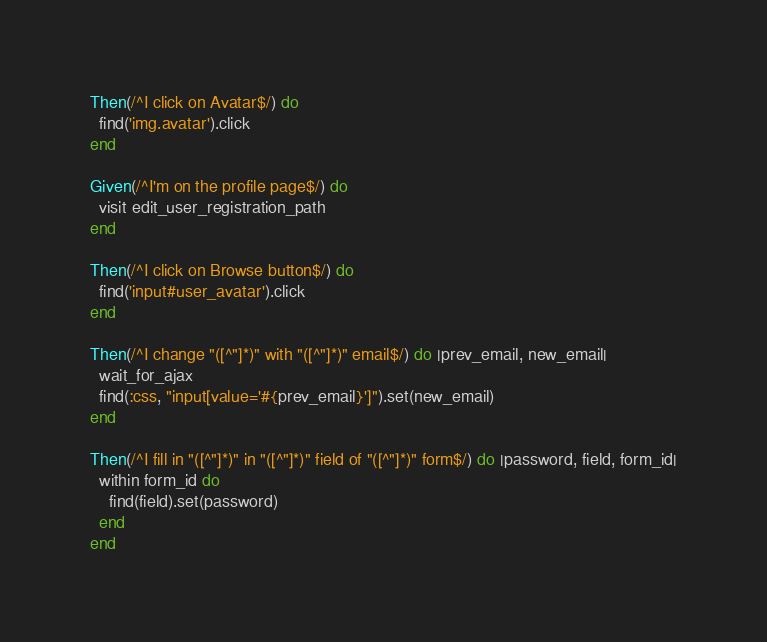<code> <loc_0><loc_0><loc_500><loc_500><_Ruby_>Then(/^I click on Avatar$/) do
  find('img.avatar').click
end

Given(/^I'm on the profile page$/) do
  visit edit_user_registration_path
end

Then(/^I click on Browse button$/) do
  find('input#user_avatar').click
end

Then(/^I change "([^"]*)" with "([^"]*)" email$/) do |prev_email, new_email|
  wait_for_ajax
  find(:css, "input[value='#{prev_email}']").set(new_email)
end

Then(/^I fill in "([^"]*)" in "([^"]*)" field of "([^"]*)" form$/) do |password, field, form_id|
  within form_id do
    find(field).set(password)
  end
end
</code> 